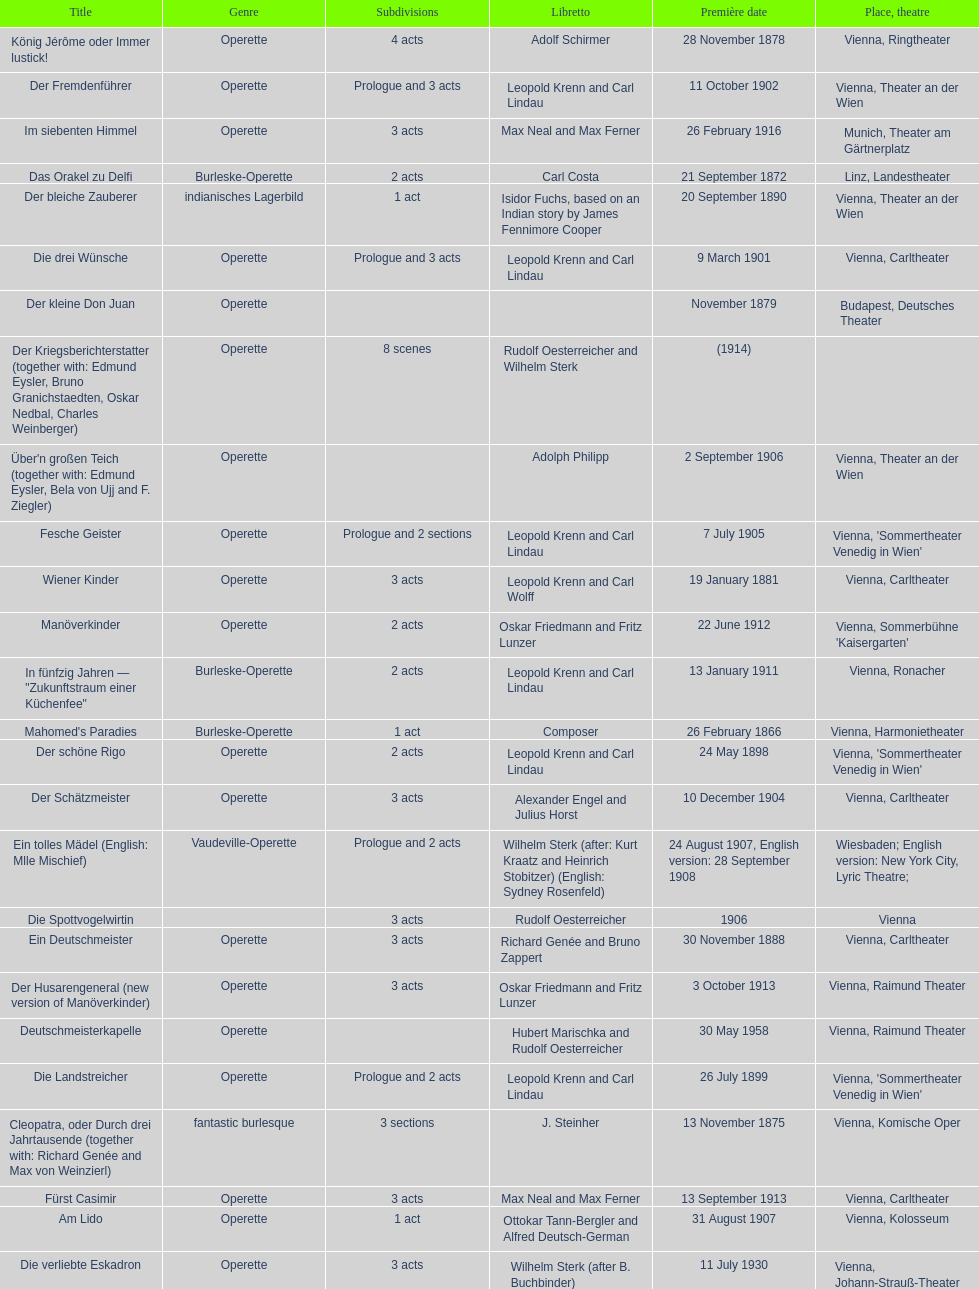How many of his operettas were 3 acts? 13. 